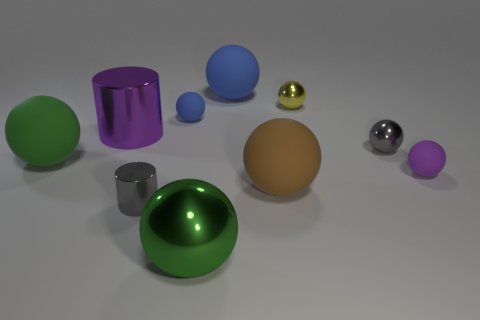What number of tiny things are either green shiny objects or brown matte things?
Your response must be concise. 0. What is the material of the brown thing?
Ensure brevity in your answer.  Rubber. There is a big thing that is behind the tiny gray shiny sphere and to the left of the tiny gray metallic cylinder; what is it made of?
Your answer should be very brief. Metal. There is a large metallic ball; is its color the same as the thing that is left of the big metallic cylinder?
Your answer should be very brief. Yes. There is a purple object that is the same size as the green matte sphere; what is its material?
Provide a short and direct response. Metal. Are there any green things that have the same material as the big blue ball?
Your response must be concise. Yes. How many shiny balls are there?
Keep it short and to the point. 3. Is the material of the large blue object the same as the blue object in front of the tiny yellow metallic sphere?
Offer a terse response. Yes. What material is the small thing that is the same color as the tiny shiny cylinder?
Ensure brevity in your answer.  Metal. How many big spheres have the same color as the tiny metal cylinder?
Your answer should be very brief. 0. 